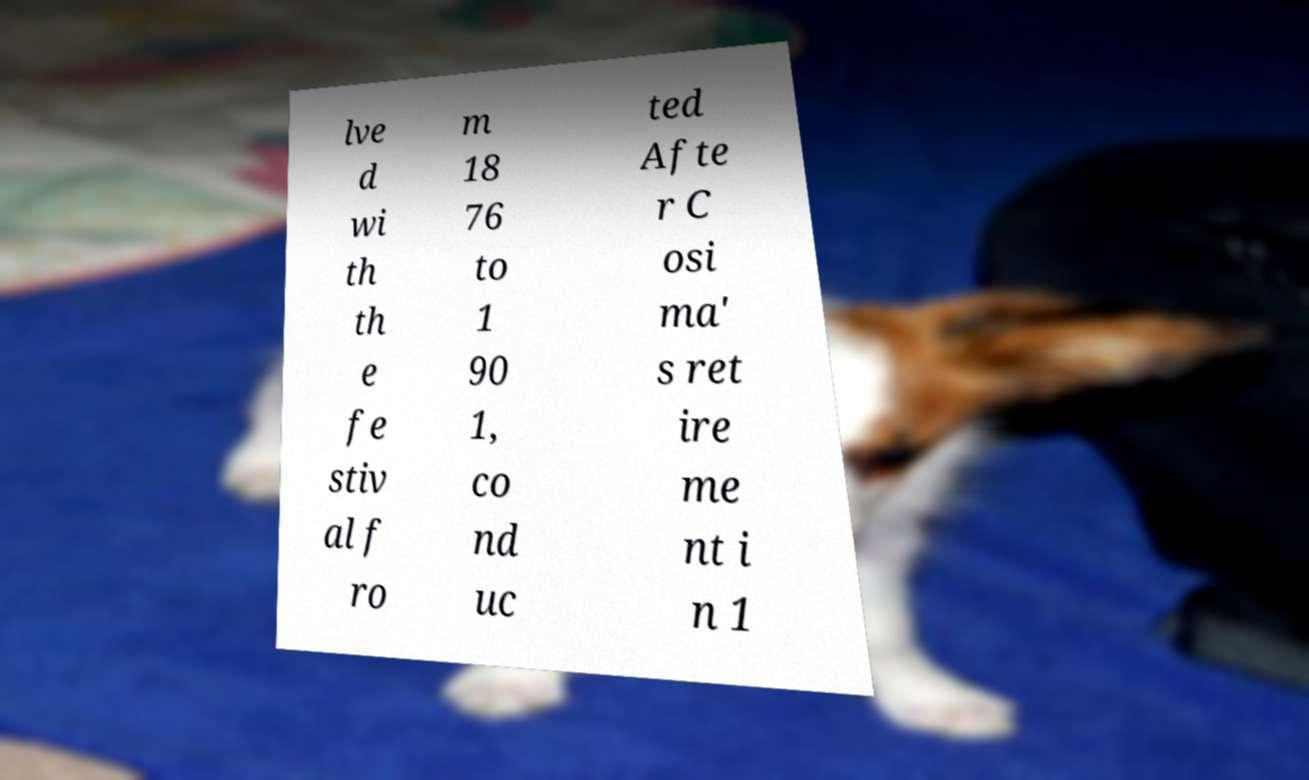What messages or text are displayed in this image? I need them in a readable, typed format. lve d wi th th e fe stiv al f ro m 18 76 to 1 90 1, co nd uc ted Afte r C osi ma' s ret ire me nt i n 1 